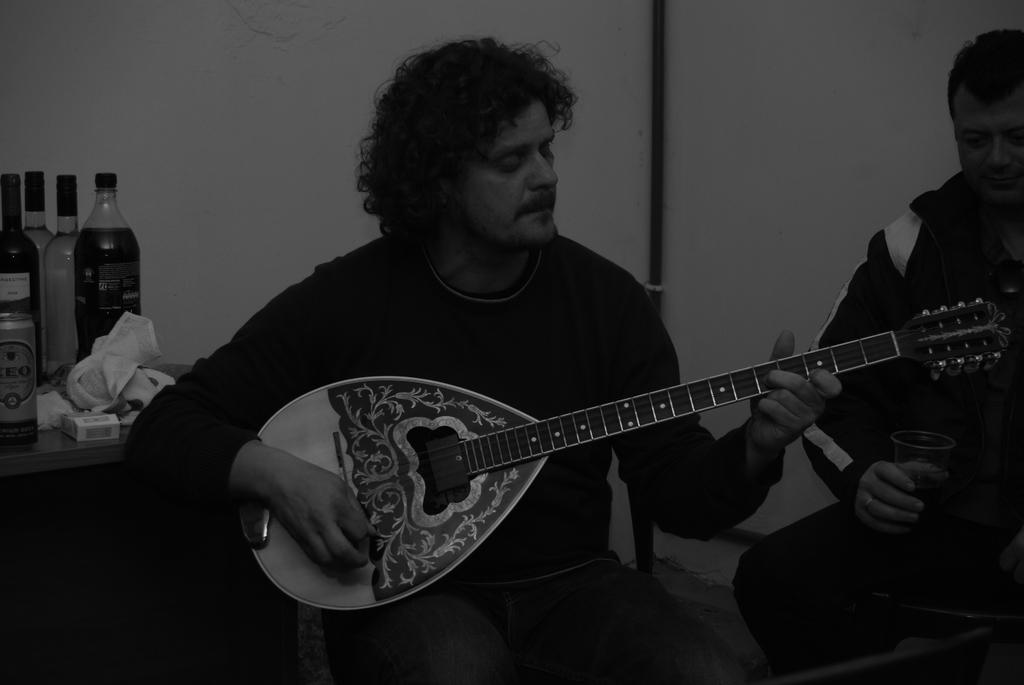What is the color of the wall in the image? The wall in the image is white. What is the man in the image doing? The man is holding a guitar in the image. What piece of furniture is present in the image? There is a table in the image. What objects are on the table? There are bottles on the table. How many eggs are on the man's mouth in the image? There are no eggs on the man's mouth in the image, as there is no mention of eggs or the man's mouth in the provided facts. 